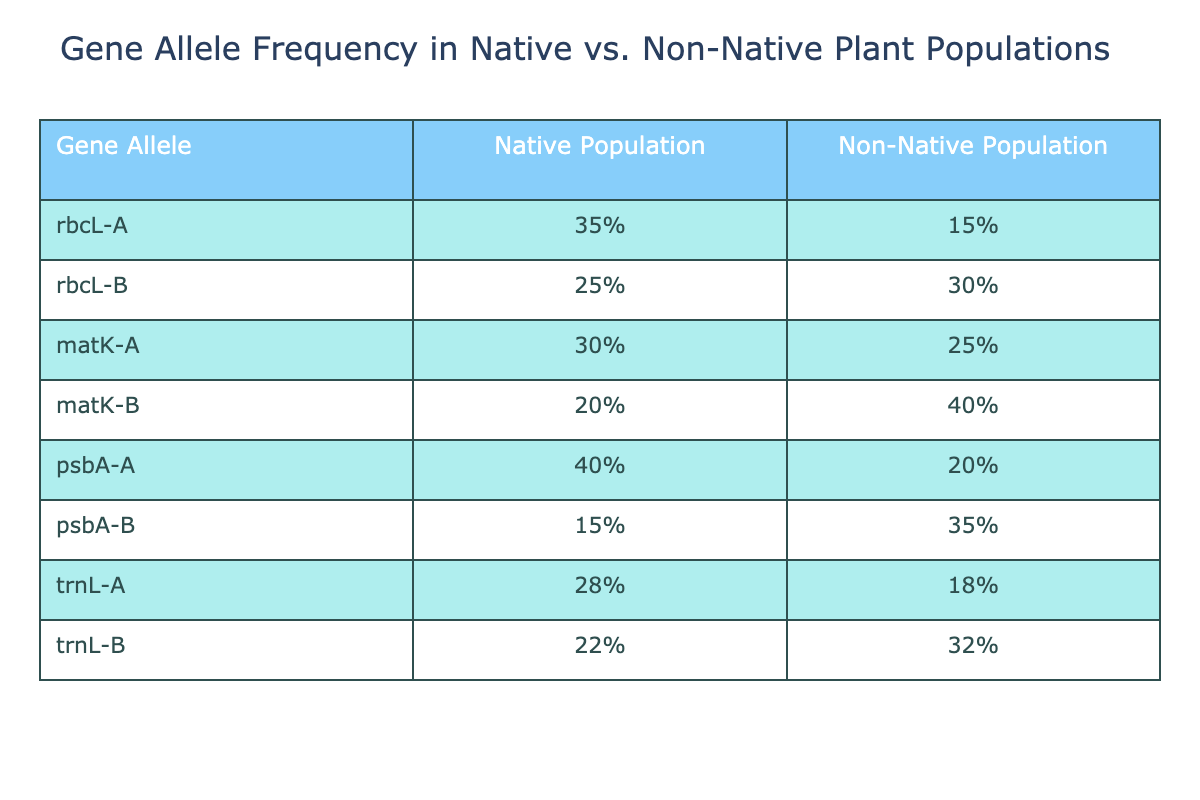What is the frequency of the rbcL-A allele in the native population? The table shows that the frequency of the rbcL-A allele in the native population is listed explicitly, which is 35%.
Answer: 35% What is the frequency of the matK-B allele in the non-native population? Referring to the table, the frequency of the matK-B allele in the non-native population is indicated as 40%.
Answer: 40% How many gene alleles have a higher frequency in native populations than in non-native populations? By examining the frequencies, the alleles rbcL-A, rbcL-B, matK-A, psbA-A, and trnL-A have higher frequencies in the native population (5 alleles).
Answer: 5 What is the difference in frequency of psbA-B between native and non-native populations? From the data, the frequency of psbA-B in the native population is 15% and in the non-native population is 35%. The difference is calculated as 35% - 15% = 20%.
Answer: 20% Is there any gene allele where the non-native population shows a higher frequency than the native population? Yes, the table indicates that for alleles such as rbcL-B, matK-B, psbA-B, and trnL-B, the non-native populations show higher frequencies than the native populations.
Answer: Yes What is the average frequency of gene alleles in the native populations? To find the average, we sum the native frequencies: 35 + 25 + 30 + 20 + 40 + 15 + 28 + 22 = 225. Then, divide by the number of alleles (8). The average is 225/8 = 28.125%.
Answer: 28.125% Which gene allele has the lowest frequency in the native population? By checking the frequencies listed for the native population, the allele with the lowest frequency is psbA-B, at 15%.
Answer: psbA-B Which gene allele has the highest frequency in the non-native population? The table shows that among all the non-native population frequencies, the allele with the highest frequency is matK-B, at 40%.
Answer: matK-B What is the combined frequency of the trnL alleles in both populations? The frequency of trnL-A in the native population is 28% and in the non-native population it is 18%. The combined frequency is calculated as 28% + 18% = 46%.
Answer: 46% How does the frequency of rbcL-B compare between native and non-native populations? The frequency of rbcL-B in the native population is 25%, while in the non-native population it is higher at 30%. Thus, the non-native population shows a greater frequency for this allele.
Answer: Non-native is higher 